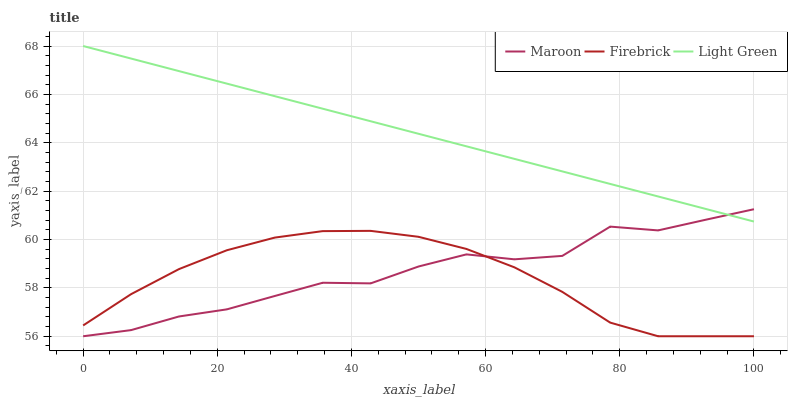Does Firebrick have the minimum area under the curve?
Answer yes or no. Yes. Does Light Green have the maximum area under the curve?
Answer yes or no. Yes. Does Maroon have the minimum area under the curve?
Answer yes or no. No. Does Maroon have the maximum area under the curve?
Answer yes or no. No. Is Light Green the smoothest?
Answer yes or no. Yes. Is Maroon the roughest?
Answer yes or no. Yes. Is Maroon the smoothest?
Answer yes or no. No. Is Light Green the roughest?
Answer yes or no. No. Does Light Green have the lowest value?
Answer yes or no. No. Does Maroon have the highest value?
Answer yes or no. No. Is Firebrick less than Light Green?
Answer yes or no. Yes. Is Light Green greater than Firebrick?
Answer yes or no. Yes. Does Firebrick intersect Light Green?
Answer yes or no. No. 